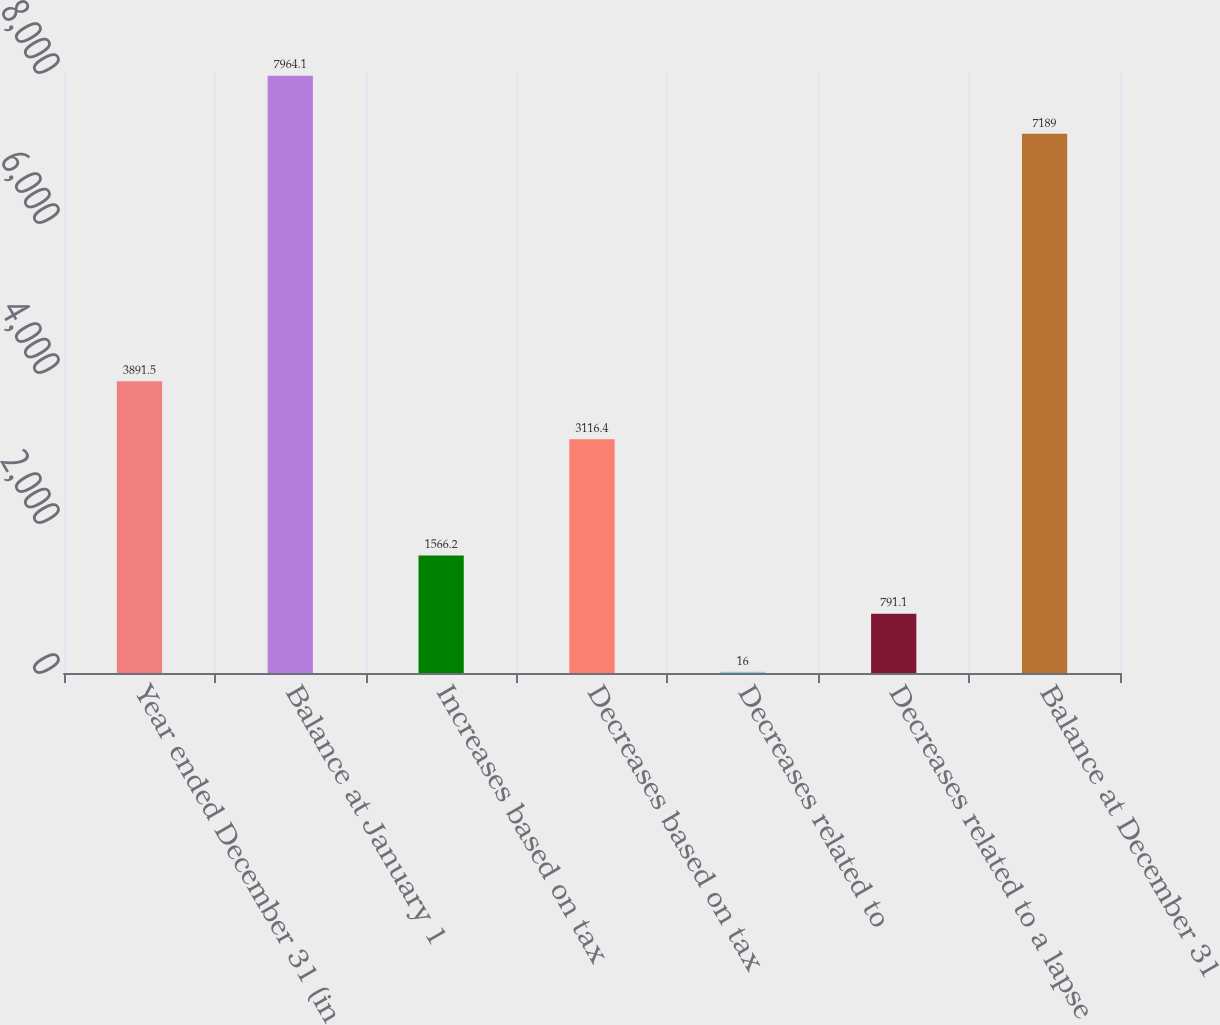Convert chart to OTSL. <chart><loc_0><loc_0><loc_500><loc_500><bar_chart><fcel>Year ended December 31 (in<fcel>Balance at January 1<fcel>Increases based on tax<fcel>Decreases based on tax<fcel>Decreases related to<fcel>Decreases related to a lapse<fcel>Balance at December 31<nl><fcel>3891.5<fcel>7964.1<fcel>1566.2<fcel>3116.4<fcel>16<fcel>791.1<fcel>7189<nl></chart> 